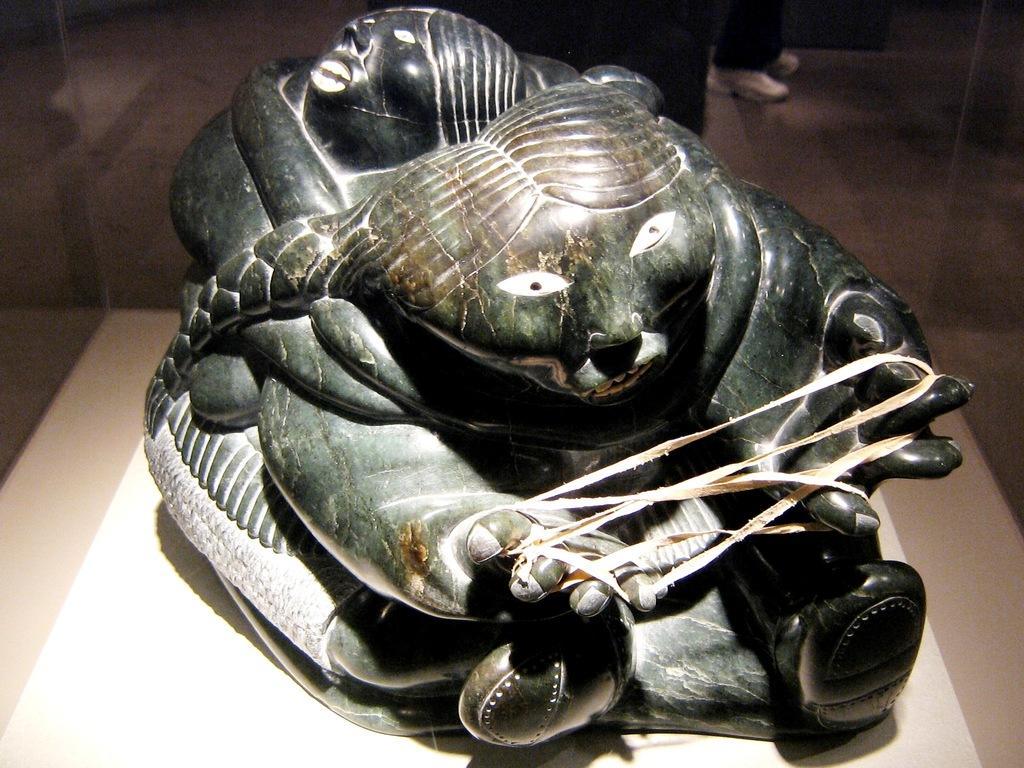How would you summarize this image in a sentence or two? In this image we can see a marble statue with some thread tied to its fingers which is placed on the surface. On the backside we can see the legs of a person on the floor. 